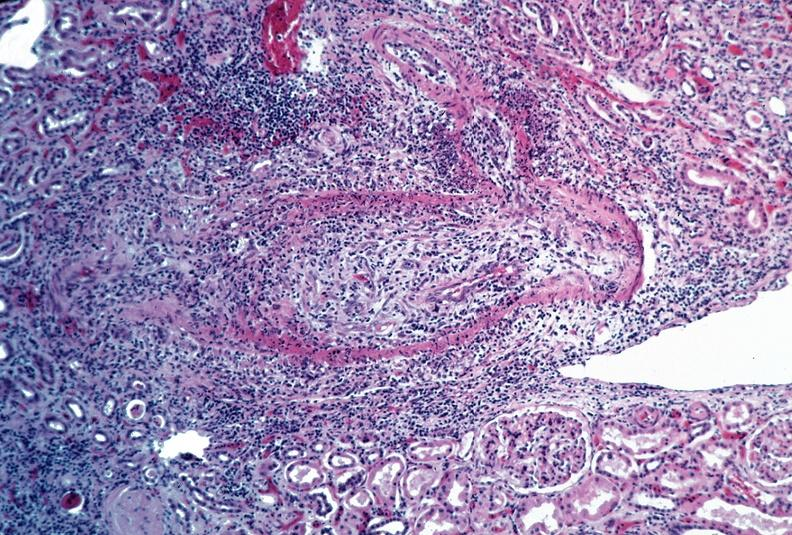what does this image show?
Answer the question using a single word or phrase. Vasculitis 